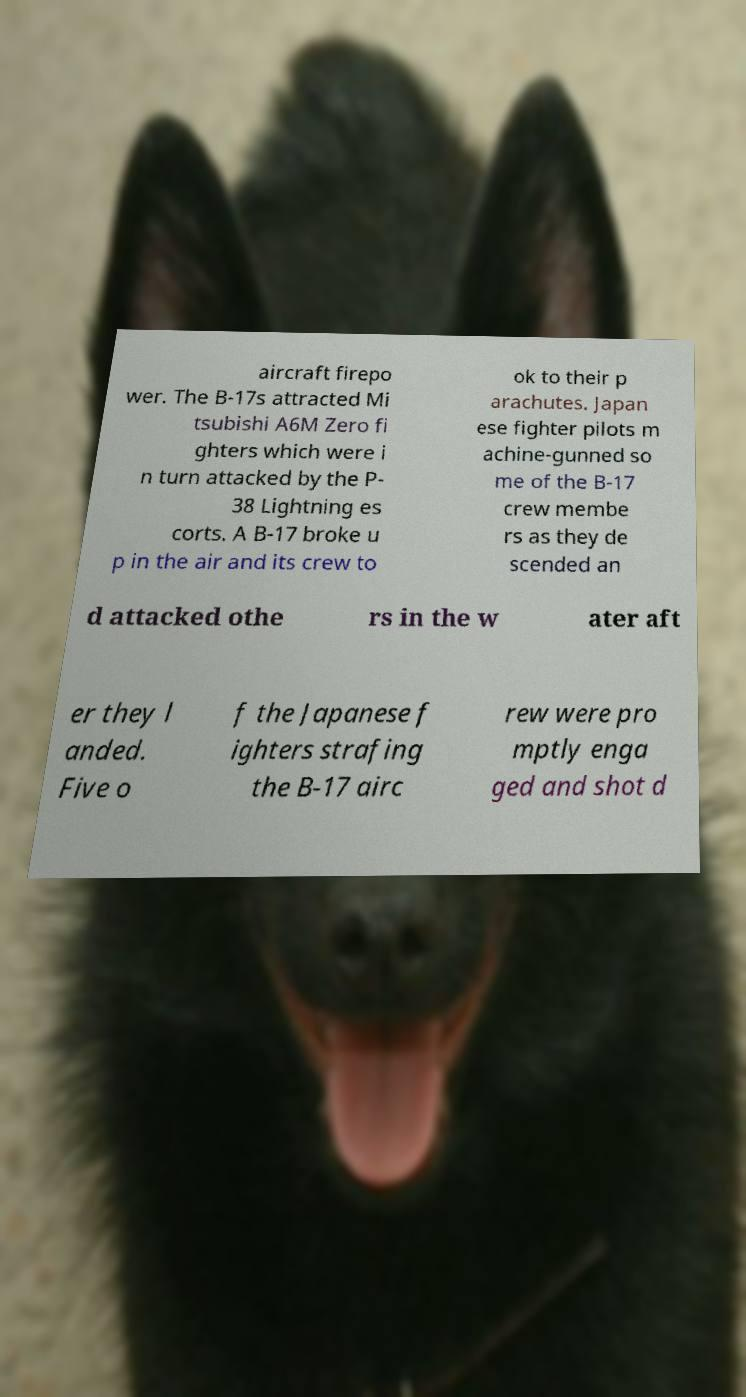There's text embedded in this image that I need extracted. Can you transcribe it verbatim? aircraft firepo wer. The B-17s attracted Mi tsubishi A6M Zero fi ghters which were i n turn attacked by the P- 38 Lightning es corts. A B-17 broke u p in the air and its crew to ok to their p arachutes. Japan ese fighter pilots m achine-gunned so me of the B-17 crew membe rs as they de scended an d attacked othe rs in the w ater aft er they l anded. Five o f the Japanese f ighters strafing the B-17 airc rew were pro mptly enga ged and shot d 